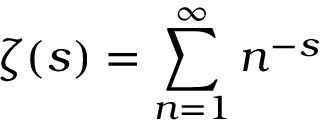<formula> <loc_0><loc_0><loc_500><loc_500>\zeta ( s ) = \sum _ { n = 1 } ^ { \infty } n ^ { - s }</formula> 